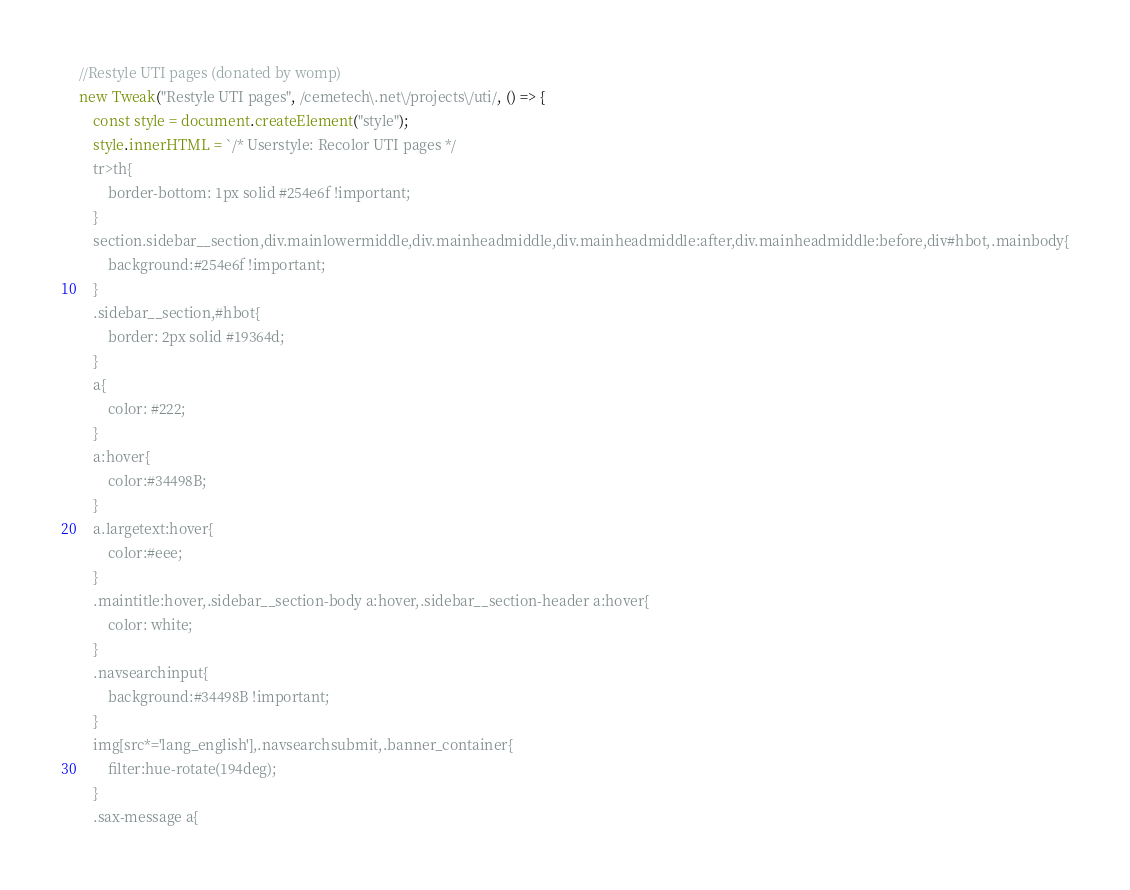Convert code to text. <code><loc_0><loc_0><loc_500><loc_500><_JavaScript_>//Restyle UTI pages (donated by womp)
new Tweak("Restyle UTI pages", /cemetech\.net\/projects\/uti/, () => {
	const style = document.createElement("style");
	style.innerHTML = `/* Userstyle: Recolor UTI pages */
	tr>th{
		border-bottom: 1px solid #254e6f !important;
	}
	section.sidebar__section,div.mainlowermiddle,div.mainheadmiddle,div.mainheadmiddle:after,div.mainheadmiddle:before,div#hbot,.mainbody{
		background:#254e6f !important;
	}
	.sidebar__section,#hbot{
		border: 2px solid #19364d;
	}
	a{
		color: #222;
	}
	a:hover{
		color:#34498B;
	}
	a.largetext:hover{
		color:#eee;
	}
	.maintitle:hover,.sidebar__section-body a:hover,.sidebar__section-header a:hover{
		color: white;
	}
	.navsearchinput{
		background:#34498B !important;
	}
	img[src*='lang_english'],.navsearchsubmit,.banner_container{
		filter:hue-rotate(194deg);
	}
	.sax-message a{</code> 